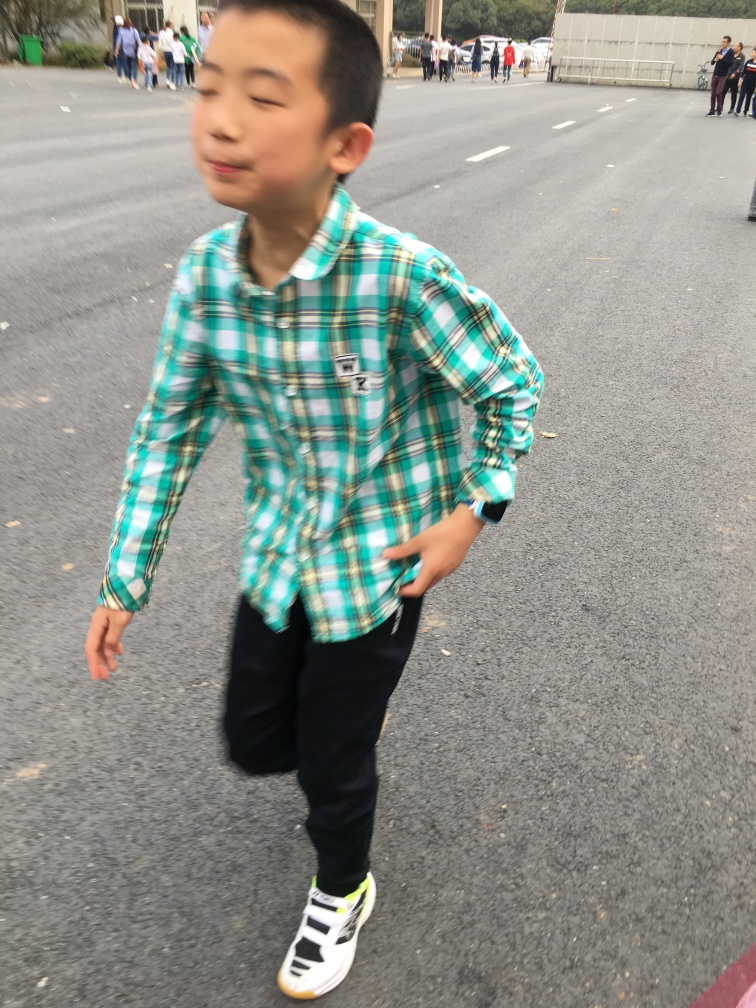Does the image have good overall sharpness?
A. No
B. Yes
Answer with the option's letter from the given choices directly.
 A. 